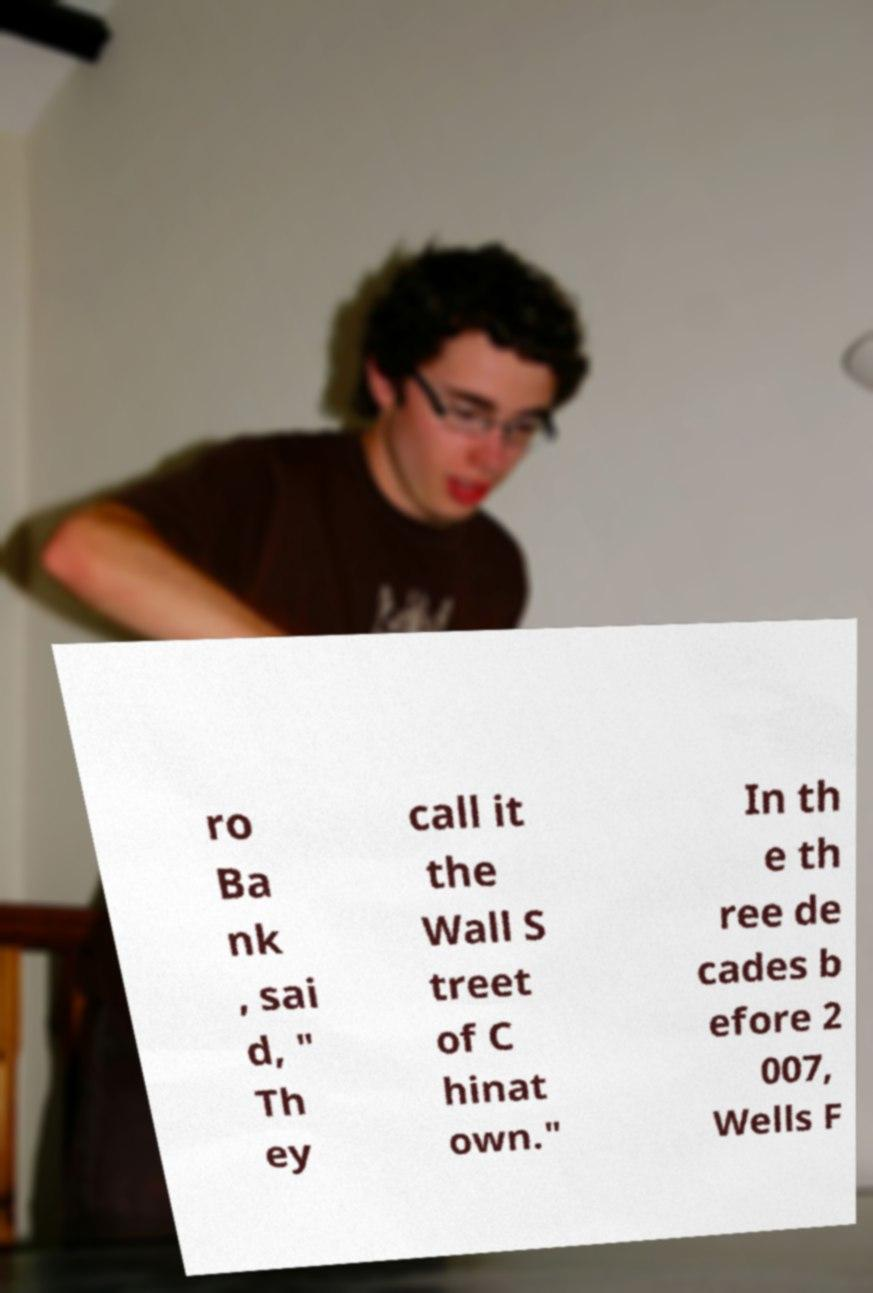There's text embedded in this image that I need extracted. Can you transcribe it verbatim? ro Ba nk , sai d, " Th ey call it the Wall S treet of C hinat own." In th e th ree de cades b efore 2 007, Wells F 